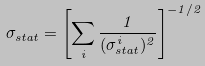<formula> <loc_0><loc_0><loc_500><loc_500>\sigma _ { s t a t } = \left [ \sum _ { i } \frac { 1 } { ( \sigma _ { s t a t } ^ { i } ) ^ { 2 } } \right ] ^ { - 1 / 2 }</formula> 